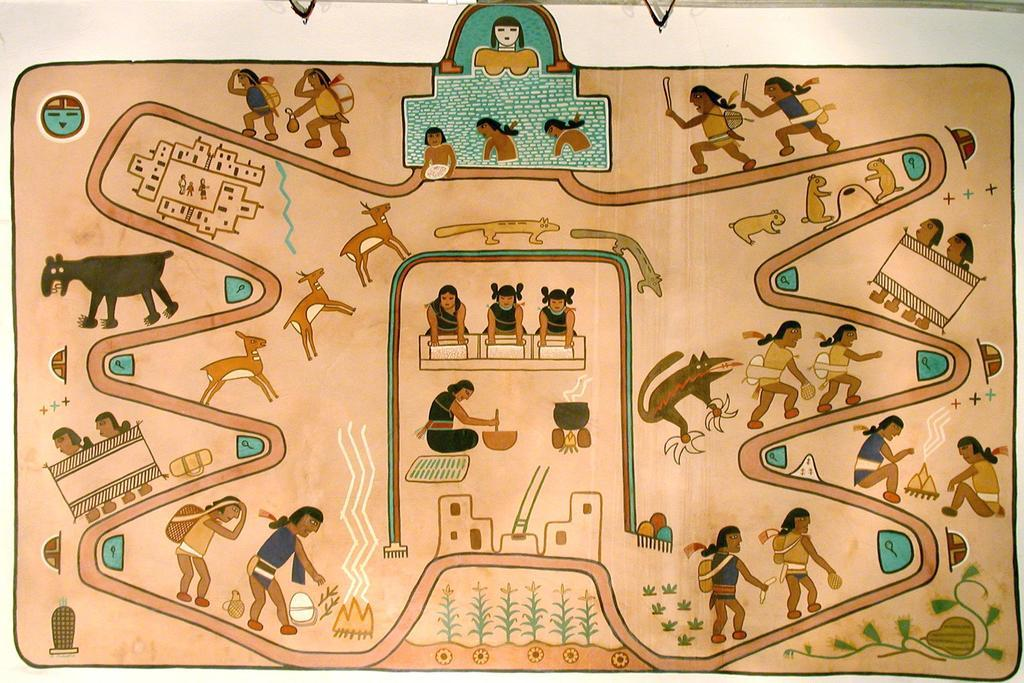What type of artwork is shown in the image? The image appears to be a wall painting. What subjects are depicted in the painting? There are animals, a group of people, and plants depicted in the painting. What type of vegetation is shown in the painting? There is grass depicted in the painting. Where might this painting be displayed? The painting may be displayed in a room. What type of book is being read by the person in the painting? There is no person reading a book in the painting; the image only shows animals, people, plants, and grass. What color is the ring worn by the animal in the painting? There is no ring worn by any animal in the painting; the image only shows animals, people, plants, and grass. 